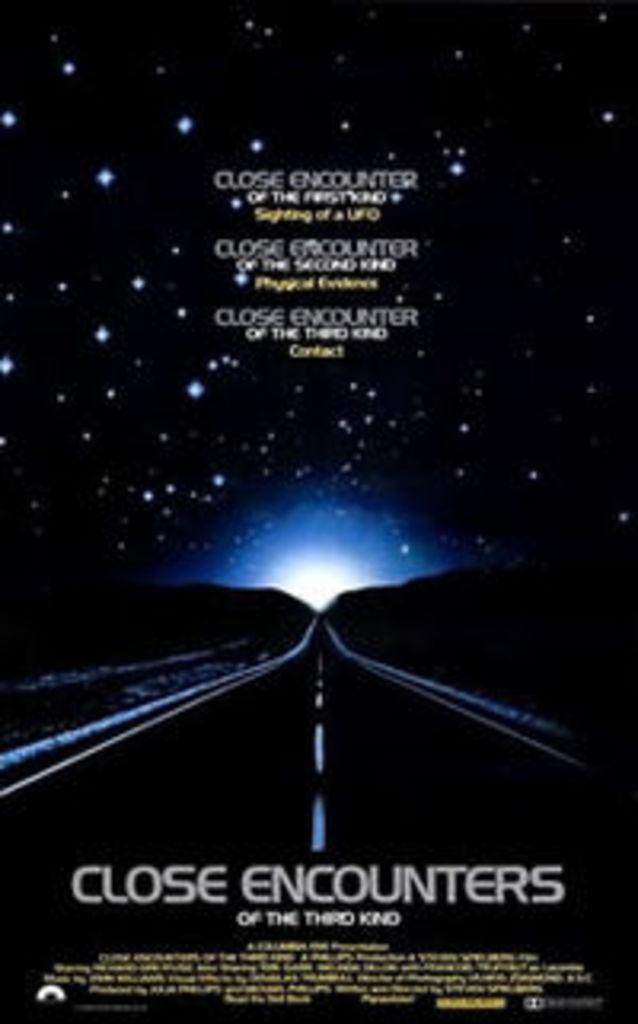Provide a one-sentence caption for the provided image. A movie poster for the 1970's classic movie "Close Encounters of the Third Kind". 